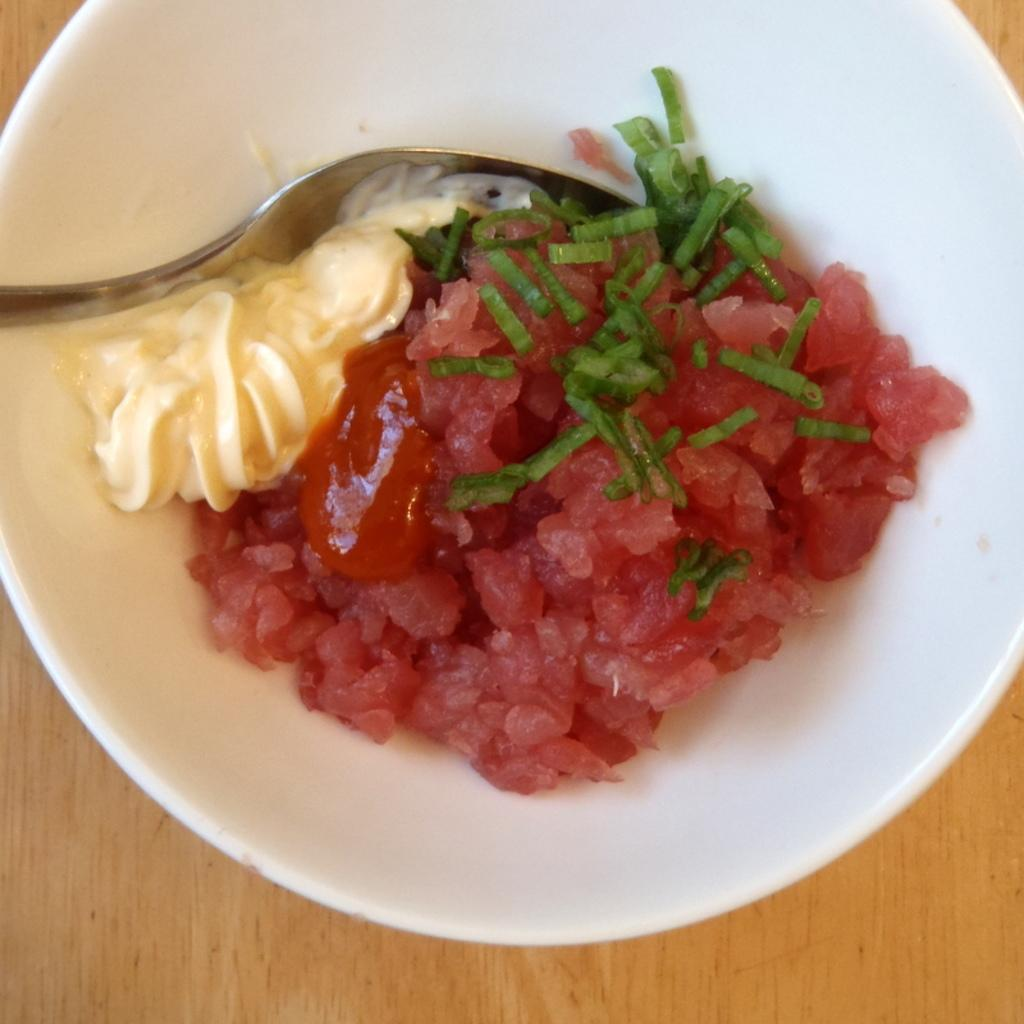What is the main subject of the image? There is a food item in the image. How is the food item presented? The food item is in a white bowl. What utensil is visible in the image? There is a spoon in the image. Can you describe the ocean waves in the image? There is no ocean or waves present in the image; it features a food item in a white bowl and a spoon. What type of horn can be seen in the image? There is no horn present in the image. 